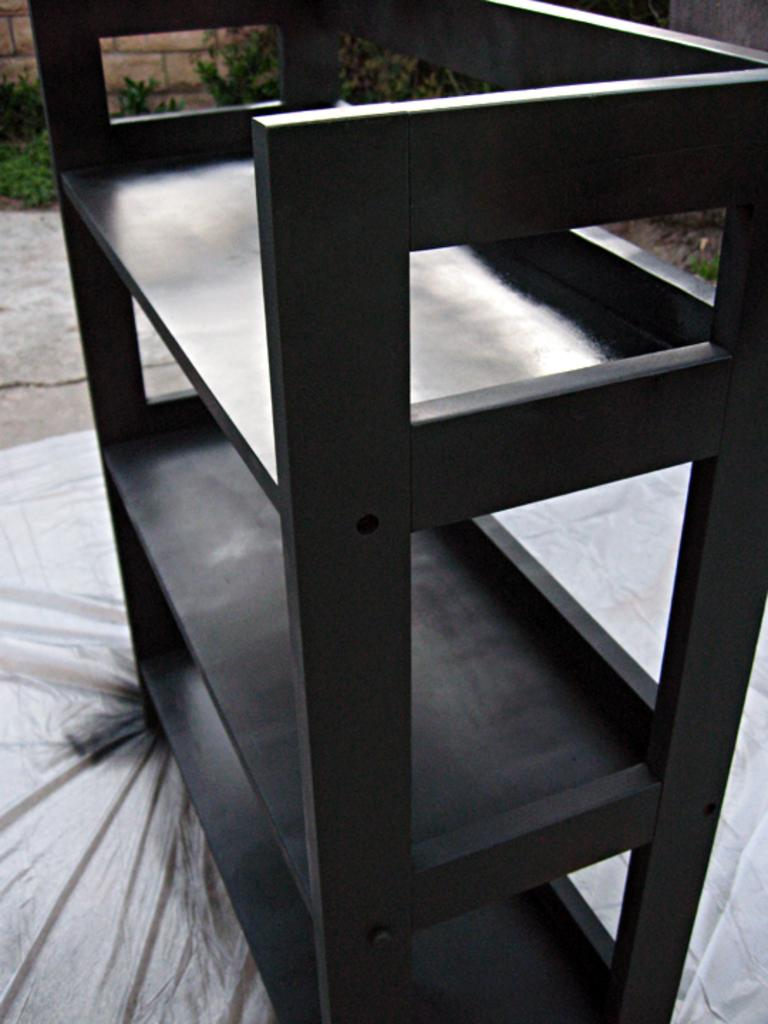What is located in the center of the image? There is a rack in the center of the image. What can be seen in the background of the image? There is a wall and plants in the background of the image. What type of hospital is visible in the image? There is no hospital present in the image. What facial expression can be seen on the plants in the image? Plants do not have facial expressions, so this cannot be determined from the image. 